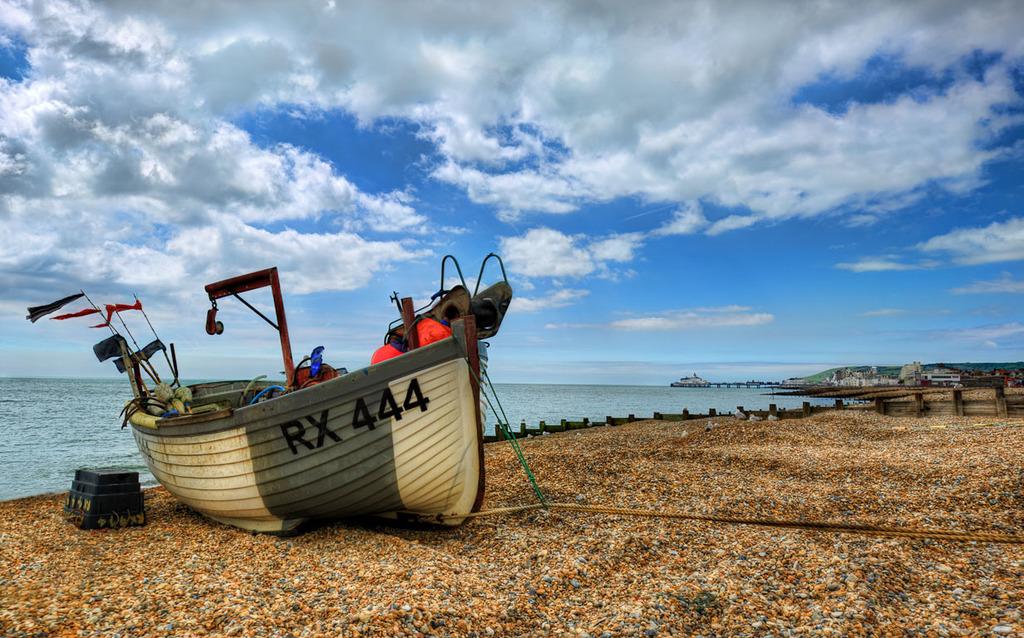What is the number of the boat?
Your response must be concise. 444. What letters are shown before the number?
Your answer should be compact. Rx. 